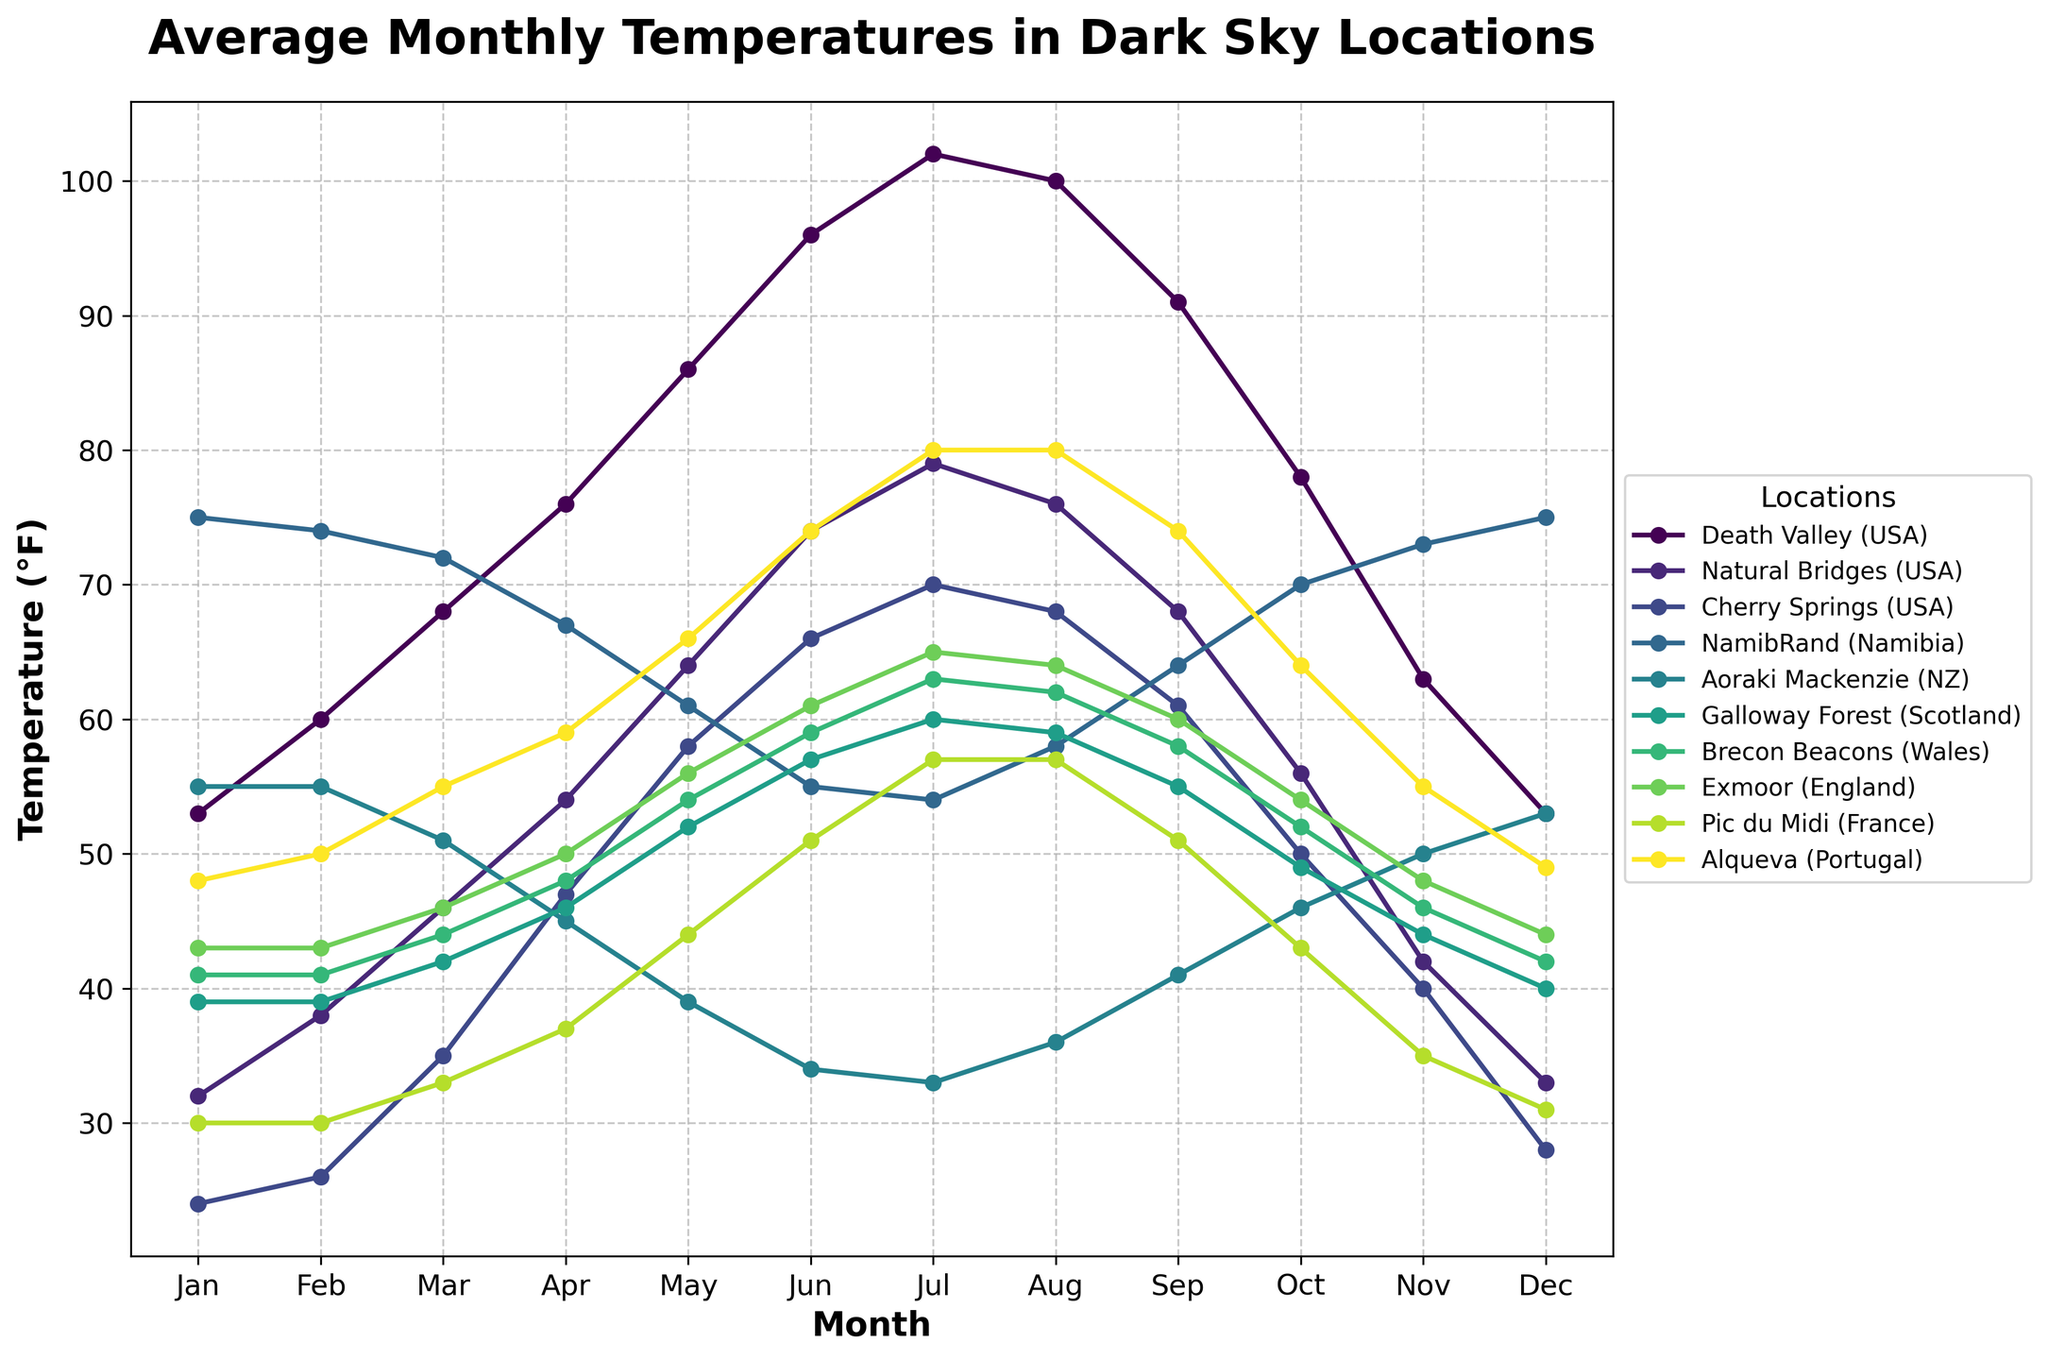Which location experiences the highest temperature in July? Look for the peak temperature in the line representing July across all locations and identify the corresponding location. The highest point in July is at 102°F, which corresponds to Death Valley.
Answer: Death Valley What is the average temperature in NamibRand for the winter months (June, July, and August)? Calculate the average by summing the temperatures for June (55°F), July (54°F), and August (58°F) and then dividing by the number of months, which is 3: (55 + 54 + 58) / 3 = 55.67°F.
Answer: 55.67°F Which location shows the least variation in temperatures throughout the year? Check the variation by observing the range of temperatures (difference between the highest and lowest points) for each location. NamibRand experiences the least variation as the temperatures range from approximately 54°F to 75°F.
Answer: NamibRand How does the average temperature in Cherry Springs in May compare to that in Pic du Midi in July? Read the temperatures for the specified months at the two locations and compare: Cherry Springs in May is 58°F, and Pic du Midi in July is 57°F.
Answer: Cherry Springs has a higher temperature in May Which months have the lowest and highest temperatures in Aoraki Mackenzie? Identify the lowest and highest points on the Aoraki Mackenzie line. The lowest temperature is 33°F in July, and the highest is 55°F in January and February.
Answer: The lowest temperature is in July, and the highest is in January and February What is the temperature difference between Death Valley and Galloway Forest in April? Subtract the temperature of Galloway Forest in April (46°F) from that of Death Valley (76°F): 76 - 46 = 30°F.
Answer: 30°F Which two locations have the closest average temperatures in December? Compare the December temperatures across all locations and find the smallest difference. Exmoor and Brecon Beacons both have temperatures of 44°F and 42°F, respectively.
Answer: Exmoor and Brecon Beacons During which month does Cherry Springs have the highest temperature, and what is it? Identify the peak point on the Cherry Springs line. July has the highest temperature at 70°F.
Answer: July, 70°F 